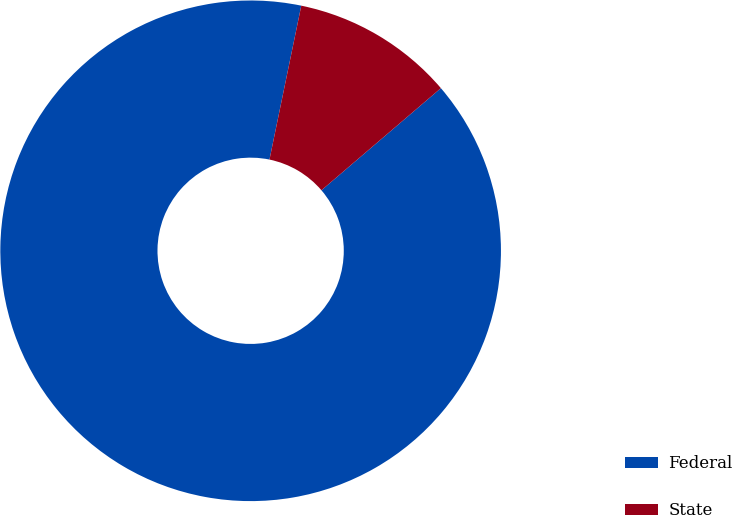Convert chart. <chart><loc_0><loc_0><loc_500><loc_500><pie_chart><fcel>Federal<fcel>State<nl><fcel>89.5%<fcel>10.5%<nl></chart> 